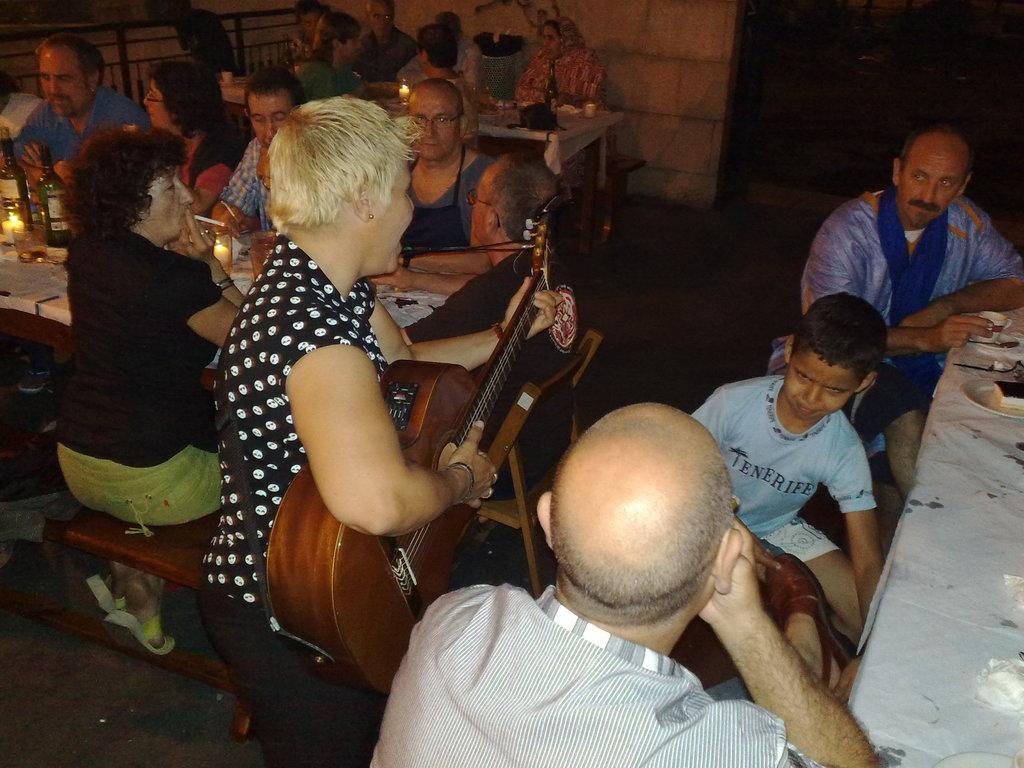Could you give a brief overview of what you see in this image? This picture is taken inside a restaurant. There are few people sitting on chairs at the tables. On the table there are bottles, candles, cups, plates, spoons and food. There is woman in the center standing and playing guitar. At the above left corner of the image there is railing and in the background there is wall. 